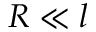<formula> <loc_0><loc_0><loc_500><loc_500>R \ll l</formula> 